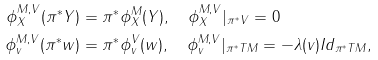Convert formula to latex. <formula><loc_0><loc_0><loc_500><loc_500>\phi ^ { M , V } _ { X } ( \pi ^ { * } Y ) & = \pi ^ { * } \phi ^ { M } _ { X } ( Y ) , \quad \phi ^ { M , V } _ { X } | _ { \pi ^ { * } V } = 0 \\ \phi ^ { M , V } _ { v } ( \pi ^ { * } w ) & = \pi ^ { * } \phi ^ { V } _ { v } ( w ) , \quad \phi ^ { M , V } _ { v } | _ { \pi ^ { * } T M } = - \lambda ( v ) I d _ { \pi ^ { * } T M } ,</formula> 